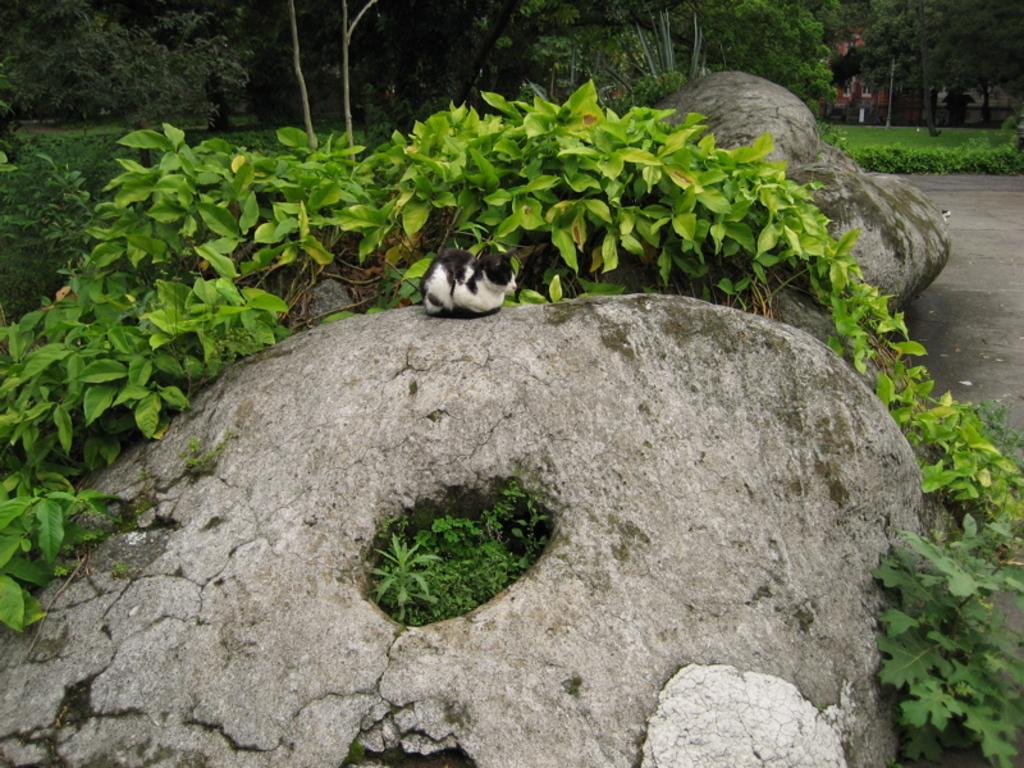What is at the bottom of the image? There are stones at the bottom of the image. What can be seen in the middle of the image? There is a cat sitting on a rock in the middle of the image. What is visible in the background of the image? There are trees in the background of the image. What type of slave is depicted in the image? There is no slave present in the image; it features a cat sitting on a rock. What material is the cat's collar made of in the image? There is no collar visible on the cat in the image. 